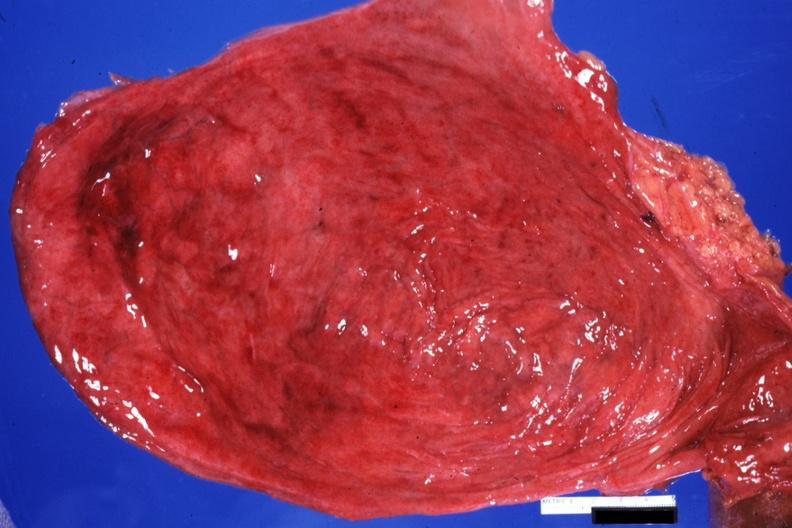s schwannoma present?
Answer the question using a single word or phrase. No 